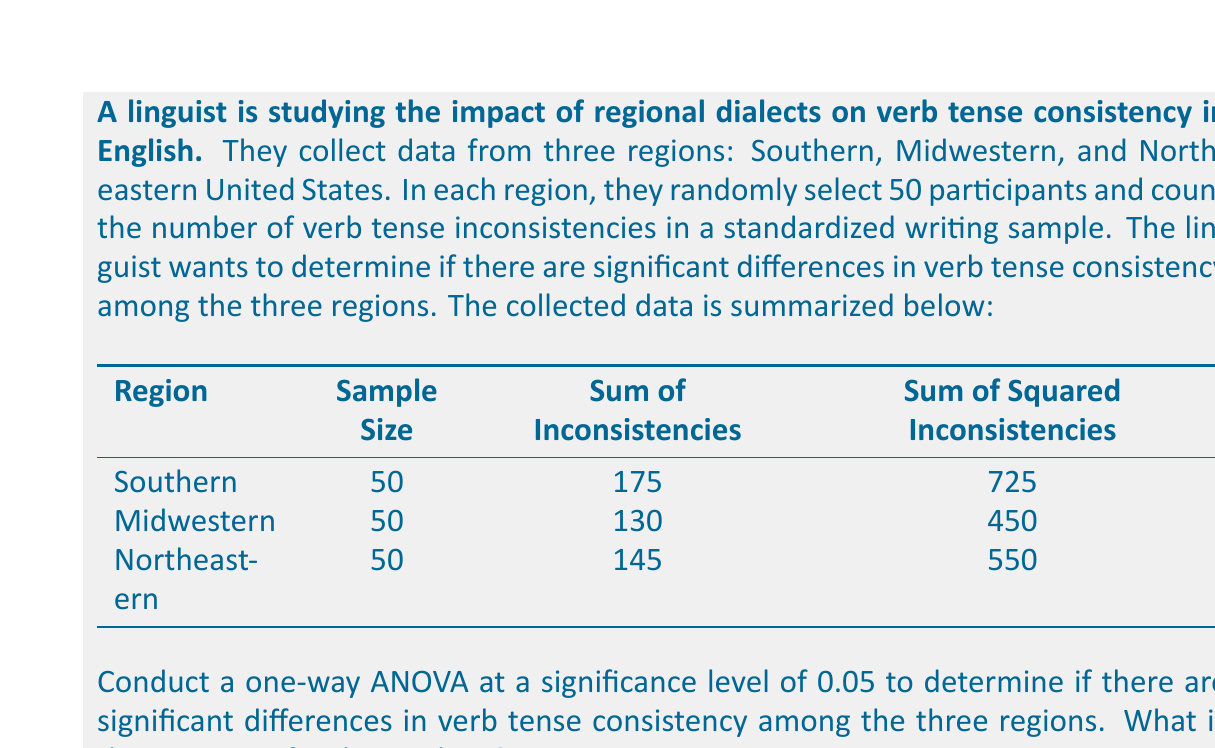Could you help me with this problem? To conduct a one-way ANOVA, we need to calculate the following:

1. Grand Mean
2. Sum of Squares Total (SST)
3. Sum of Squares Between (SSB)
4. Sum of Squares Within (SSW)
5. Degrees of freedom
6. Mean Square Between (MSB)
7. Mean Square Within (MSW)
8. F-statistic

Step 1: Calculate the Grand Mean
$$\bar{X} = \frac{\text{Total Sum of Inconsistencies}}{\text{Total Sample Size}} = \frac{175 + 130 + 145}{150} = 3$$

Step 2: Calculate SST
$$SST = \sum_{i=1}^{3}\sum_{j=1}^{50} X_{ij}^2 - \frac{(\sum_{i=1}^{3}\sum_{j=1}^{50} X_{ij})^2}{N}$$
$$SST = (725 + 450 + 550) - \frac{(175 + 130 + 145)^2}{150} = 1725 - 1350 = 375$$

Step 3: Calculate SSB
$$SSB = \sum_{i=1}^{3} \frac{(\sum_{j=1}^{50} X_{ij})^2}{n_i} - \frac{(\sum_{i=1}^{3}\sum_{j=1}^{50} X_{ij})^2}{N}$$
$$SSB = \frac{175^2 + 130^2 + 145^2}{50} - \frac{450^2}{150} = 1362.5 - 1350 = 12.5$$

Step 4: Calculate SSW
$$SSW = SST - SSB = 375 - 12.5 = 362.5$$

Step 5: Degrees of freedom
$$df_{between} = k - 1 = 3 - 1 = 2$$
$$df_{within} = N - k = 150 - 3 = 147$$
Where k is the number of groups and N is the total sample size.

Step 6: Calculate MSB
$$MSB = \frac{SSB}{df_{between}} = \frac{12.5}{2} = 6.25$$

Step 7: Calculate MSW
$$MSW = \frac{SSW}{df_{within}} = \frac{362.5}{147} \approx 2.466$$

Step 8: Calculate F-statistic
$$F = \frac{MSB}{MSW} = \frac{6.25}{2.466} \approx 2.534$$

The F-statistic for this analysis is approximately 2.534.
Answer: The F-statistic for this one-way ANOVA analysis is approximately 2.534. 